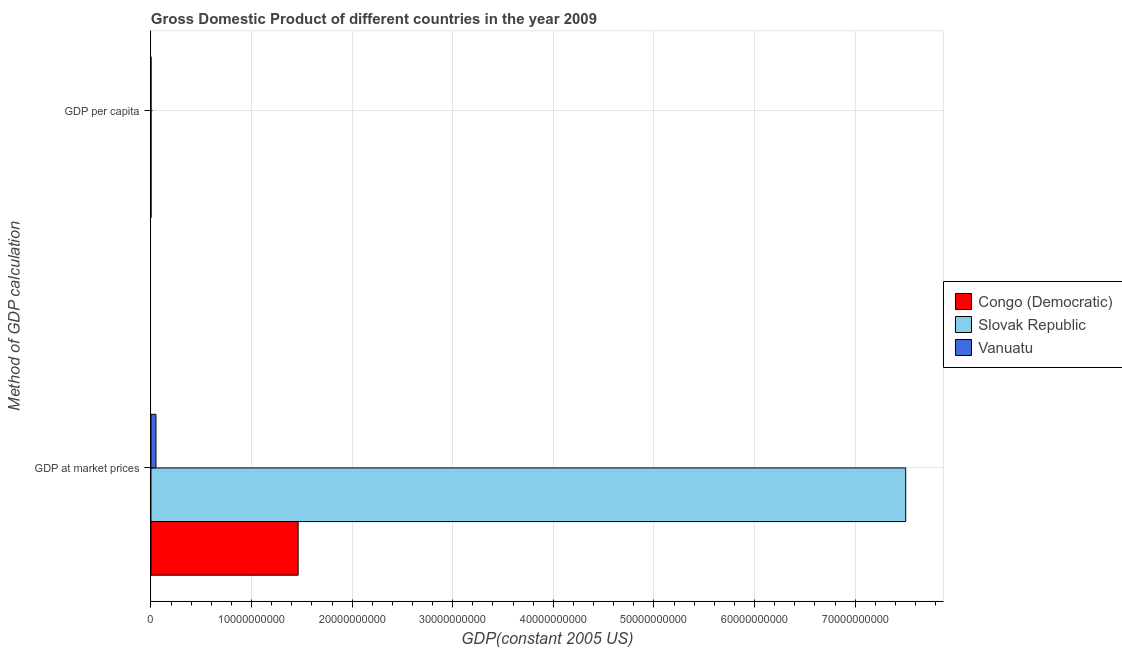How many different coloured bars are there?
Keep it short and to the point. 3. How many groups of bars are there?
Your response must be concise. 2. Are the number of bars on each tick of the Y-axis equal?
Keep it short and to the point. Yes. How many bars are there on the 1st tick from the top?
Make the answer very short. 3. What is the label of the 1st group of bars from the top?
Your response must be concise. GDP per capita. What is the gdp per capita in Slovak Republic?
Offer a very short reply. 1.39e+04. Across all countries, what is the maximum gdp per capita?
Provide a succinct answer. 1.39e+04. Across all countries, what is the minimum gdp per capita?
Provide a succinct answer. 229.14. In which country was the gdp at market prices maximum?
Provide a short and direct response. Slovak Republic. In which country was the gdp per capita minimum?
Make the answer very short. Congo (Democratic). What is the total gdp at market prices in the graph?
Offer a terse response. 9.02e+1. What is the difference between the gdp per capita in Slovak Republic and that in Vanuatu?
Your answer should be compact. 1.18e+04. What is the difference between the gdp per capita in Congo (Democratic) and the gdp at market prices in Slovak Republic?
Your answer should be very brief. -7.50e+1. What is the average gdp per capita per country?
Give a very brief answer. 5435.19. What is the difference between the gdp per capita and gdp at market prices in Congo (Democratic)?
Make the answer very short. -1.46e+1. In how many countries, is the gdp at market prices greater than 4000000000 US$?
Your answer should be compact. 2. What is the ratio of the gdp per capita in Vanuatu to that in Slovak Republic?
Offer a very short reply. 0.15. In how many countries, is the gdp per capita greater than the average gdp per capita taken over all countries?
Provide a short and direct response. 1. What does the 2nd bar from the top in GDP at market prices represents?
Offer a very short reply. Slovak Republic. What does the 3rd bar from the bottom in GDP per capita represents?
Provide a short and direct response. Vanuatu. How many bars are there?
Make the answer very short. 6. How many countries are there in the graph?
Make the answer very short. 3. Are the values on the major ticks of X-axis written in scientific E-notation?
Your response must be concise. No. Does the graph contain grids?
Offer a very short reply. Yes. Where does the legend appear in the graph?
Give a very brief answer. Center right. How many legend labels are there?
Make the answer very short. 3. What is the title of the graph?
Give a very brief answer. Gross Domestic Product of different countries in the year 2009. What is the label or title of the X-axis?
Ensure brevity in your answer.  GDP(constant 2005 US). What is the label or title of the Y-axis?
Your response must be concise. Method of GDP calculation. What is the GDP(constant 2005 US) in Congo (Democratic) in GDP at market prices?
Provide a succinct answer. 1.46e+1. What is the GDP(constant 2005 US) of Slovak Republic in GDP at market prices?
Your answer should be very brief. 7.50e+1. What is the GDP(constant 2005 US) of Vanuatu in GDP at market prices?
Your answer should be very brief. 4.96e+08. What is the GDP(constant 2005 US) of Congo (Democratic) in GDP per capita?
Your response must be concise. 229.14. What is the GDP(constant 2005 US) of Slovak Republic in GDP per capita?
Your answer should be very brief. 1.39e+04. What is the GDP(constant 2005 US) of Vanuatu in GDP per capita?
Offer a very short reply. 2147.06. Across all Method of GDP calculation, what is the maximum GDP(constant 2005 US) of Congo (Democratic)?
Your response must be concise. 1.46e+1. Across all Method of GDP calculation, what is the maximum GDP(constant 2005 US) of Slovak Republic?
Give a very brief answer. 7.50e+1. Across all Method of GDP calculation, what is the maximum GDP(constant 2005 US) in Vanuatu?
Provide a succinct answer. 4.96e+08. Across all Method of GDP calculation, what is the minimum GDP(constant 2005 US) of Congo (Democratic)?
Ensure brevity in your answer.  229.14. Across all Method of GDP calculation, what is the minimum GDP(constant 2005 US) of Slovak Republic?
Ensure brevity in your answer.  1.39e+04. Across all Method of GDP calculation, what is the minimum GDP(constant 2005 US) of Vanuatu?
Keep it short and to the point. 2147.06. What is the total GDP(constant 2005 US) in Congo (Democratic) in the graph?
Keep it short and to the point. 1.46e+1. What is the total GDP(constant 2005 US) in Slovak Republic in the graph?
Make the answer very short. 7.50e+1. What is the total GDP(constant 2005 US) in Vanuatu in the graph?
Give a very brief answer. 4.96e+08. What is the difference between the GDP(constant 2005 US) of Congo (Democratic) in GDP at market prices and that in GDP per capita?
Keep it short and to the point. 1.46e+1. What is the difference between the GDP(constant 2005 US) of Slovak Republic in GDP at market prices and that in GDP per capita?
Ensure brevity in your answer.  7.50e+1. What is the difference between the GDP(constant 2005 US) of Vanuatu in GDP at market prices and that in GDP per capita?
Make the answer very short. 4.96e+08. What is the difference between the GDP(constant 2005 US) in Congo (Democratic) in GDP at market prices and the GDP(constant 2005 US) in Slovak Republic in GDP per capita?
Your answer should be very brief. 1.46e+1. What is the difference between the GDP(constant 2005 US) of Congo (Democratic) in GDP at market prices and the GDP(constant 2005 US) of Vanuatu in GDP per capita?
Give a very brief answer. 1.46e+1. What is the difference between the GDP(constant 2005 US) of Slovak Republic in GDP at market prices and the GDP(constant 2005 US) of Vanuatu in GDP per capita?
Your response must be concise. 7.50e+1. What is the average GDP(constant 2005 US) of Congo (Democratic) per Method of GDP calculation?
Your answer should be very brief. 7.31e+09. What is the average GDP(constant 2005 US) of Slovak Republic per Method of GDP calculation?
Provide a succinct answer. 3.75e+1. What is the average GDP(constant 2005 US) in Vanuatu per Method of GDP calculation?
Your answer should be very brief. 2.48e+08. What is the difference between the GDP(constant 2005 US) in Congo (Democratic) and GDP(constant 2005 US) in Slovak Republic in GDP at market prices?
Ensure brevity in your answer.  -6.04e+1. What is the difference between the GDP(constant 2005 US) in Congo (Democratic) and GDP(constant 2005 US) in Vanuatu in GDP at market prices?
Ensure brevity in your answer.  1.41e+1. What is the difference between the GDP(constant 2005 US) in Slovak Republic and GDP(constant 2005 US) in Vanuatu in GDP at market prices?
Provide a short and direct response. 7.45e+1. What is the difference between the GDP(constant 2005 US) in Congo (Democratic) and GDP(constant 2005 US) in Slovak Republic in GDP per capita?
Provide a short and direct response. -1.37e+04. What is the difference between the GDP(constant 2005 US) in Congo (Democratic) and GDP(constant 2005 US) in Vanuatu in GDP per capita?
Give a very brief answer. -1917.92. What is the difference between the GDP(constant 2005 US) of Slovak Republic and GDP(constant 2005 US) of Vanuatu in GDP per capita?
Give a very brief answer. 1.18e+04. What is the ratio of the GDP(constant 2005 US) of Congo (Democratic) in GDP at market prices to that in GDP per capita?
Your answer should be very brief. 6.38e+07. What is the ratio of the GDP(constant 2005 US) in Slovak Republic in GDP at market prices to that in GDP per capita?
Provide a short and direct response. 5.39e+06. What is the ratio of the GDP(constant 2005 US) in Vanuatu in GDP at market prices to that in GDP per capita?
Provide a succinct answer. 2.31e+05. What is the difference between the highest and the second highest GDP(constant 2005 US) of Congo (Democratic)?
Offer a terse response. 1.46e+1. What is the difference between the highest and the second highest GDP(constant 2005 US) in Slovak Republic?
Ensure brevity in your answer.  7.50e+1. What is the difference between the highest and the second highest GDP(constant 2005 US) of Vanuatu?
Ensure brevity in your answer.  4.96e+08. What is the difference between the highest and the lowest GDP(constant 2005 US) of Congo (Democratic)?
Give a very brief answer. 1.46e+1. What is the difference between the highest and the lowest GDP(constant 2005 US) of Slovak Republic?
Your answer should be very brief. 7.50e+1. What is the difference between the highest and the lowest GDP(constant 2005 US) of Vanuatu?
Your response must be concise. 4.96e+08. 